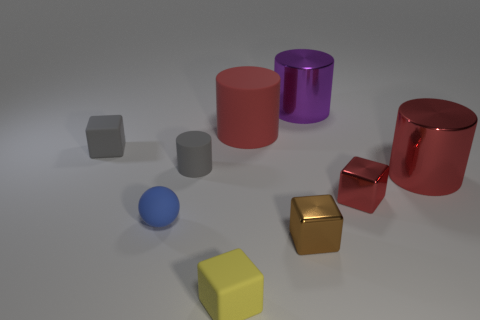Subtract 1 blocks. How many blocks are left? 3 Add 1 big red metallic things. How many objects exist? 10 Subtract all cubes. How many objects are left? 5 Subtract 0 green cylinders. How many objects are left? 9 Subtract all yellow matte objects. Subtract all small yellow objects. How many objects are left? 7 Add 6 spheres. How many spheres are left? 7 Add 3 large red metallic things. How many large red metallic things exist? 4 